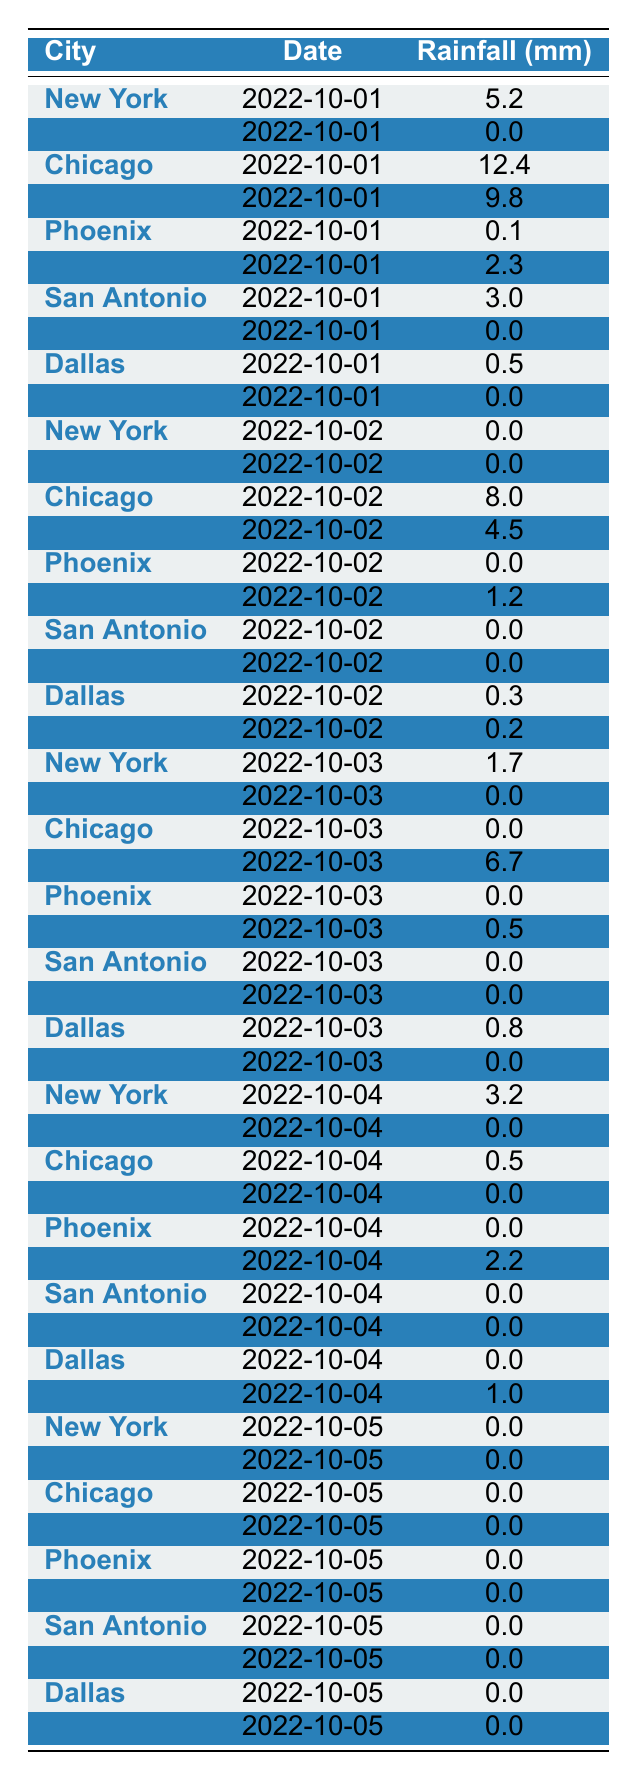What is the total rainfall measured in Chicago on October 1st? According to the table, the rainfall measured in Chicago on October 1st is 12.4 mm.
Answer: 12.4 mm How much rain did San Antonio receive on October 2nd? The table shows that San Antonio received 0.0 mm of rain on October 2nd.
Answer: 0.0 mm Which city had the highest rainfall on October 3rd? By checking the table, Houston recorded the highest rainfall at 6.7 mm on October 3rd.
Answer: Houston Did any city receive rainfall on October 5th? The table indicates that all cities received 0.0 mm of rainfall on October 5th. Therefore, no city received rainfall.
Answer: No What is the average rainfall for New York across all recorded days in the table? The recorded rainfall values for New York are 5.2, 0.0, 1.7, 3.2, and 0.0. Summing these gives 10.1 mm, and there are 5 entries, so the average is 10.1/5 = 2.02 mm.
Answer: 2.02 mm What was the total rainfall across all cities on October 1st? To find the total for October 1st, we add the rainfall amounts: 5.2 + 0.0 + 12.4 + 9.8 + 0.1 + 2.3 + 3.0 + 0.0 + 0.5 + 0.0 = 33.3 mm.
Answer: 33.3 mm Which city had consistent days of 0.0 mm rainfall over the recorded days? By examining the data, San Diego consistently shows 0.0 mm across all days recorded.
Answer: San Diego What is the difference in rainfall between Chicago and Houston on October 2nd? The table shows Chicago had 8.0 mm and Houston had 4.5 mm on October 2nd. The difference is 8.0 - 4.5 = 3.5 mm.
Answer: 3.5 mm Was there a day when Philadelphia received more than 2 mm of rain? By looking through the table, we see that Philadelphia received 2.2 mm on October 4th, but no day recorded more than 2 mm.
Answer: No On what date did Dallas first receive any rainfall? Dallas received 0.5 mm on October 1st, which is the first recorded rainfall for that city in the table.
Answer: October 1st What is the total rainfall in Los Angeles over the five days recorded? Los Angeles recorded 0.0 mm for all the five days: October 1st, 2nd, 3rd, 4th, and 5th. Therefore, the total rainfall is 0.0 mm.
Answer: 0.0 mm 